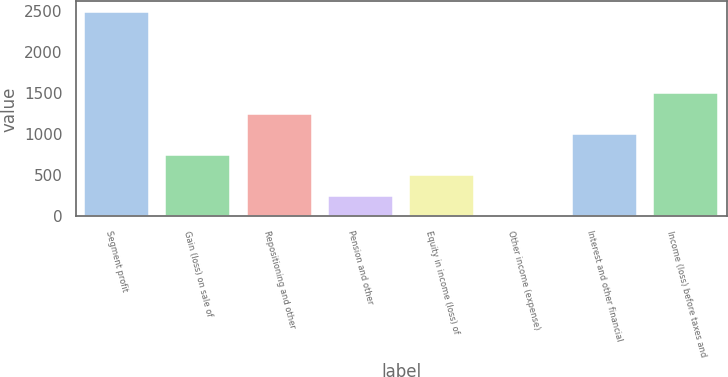Convert chart. <chart><loc_0><loc_0><loc_500><loc_500><bar_chart><fcel>Segment profit<fcel>Gain (loss) on sale of<fcel>Repositioning and other<fcel>Pension and other<fcel>Equity in income (loss) of<fcel>Other income (expense)<fcel>Interest and other financial<fcel>Income (loss) before taxes and<nl><fcel>2497<fcel>751.9<fcel>1250.5<fcel>253.3<fcel>502.6<fcel>4<fcel>1001.2<fcel>1499.8<nl></chart> 